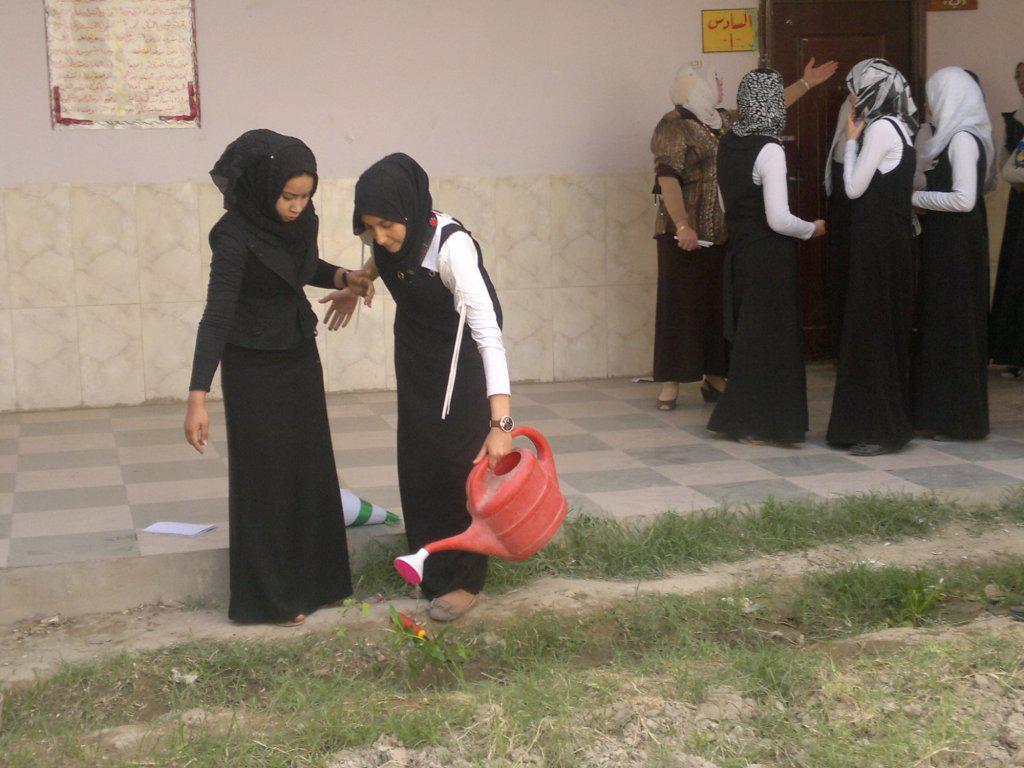Can you describe this image briefly? In the foreground of the picture there are two woman watering the plants. In foreground there is grass. On the right there are women standing. In the background it is wall, to wall there is a poster. 